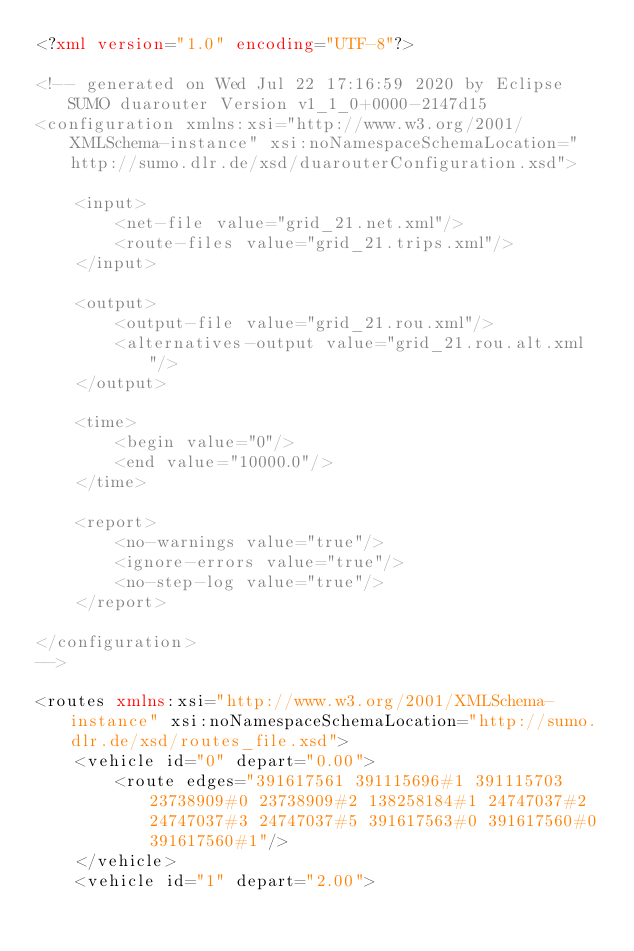<code> <loc_0><loc_0><loc_500><loc_500><_XML_><?xml version="1.0" encoding="UTF-8"?>

<!-- generated on Wed Jul 22 17:16:59 2020 by Eclipse SUMO duarouter Version v1_1_0+0000-2147d15
<configuration xmlns:xsi="http://www.w3.org/2001/XMLSchema-instance" xsi:noNamespaceSchemaLocation="http://sumo.dlr.de/xsd/duarouterConfiguration.xsd">

    <input>
        <net-file value="grid_21.net.xml"/>
        <route-files value="grid_21.trips.xml"/>
    </input>

    <output>
        <output-file value="grid_21.rou.xml"/>
        <alternatives-output value="grid_21.rou.alt.xml"/>
    </output>

    <time>
        <begin value="0"/>
        <end value="10000.0"/>
    </time>

    <report>
        <no-warnings value="true"/>
        <ignore-errors value="true"/>
        <no-step-log value="true"/>
    </report>

</configuration>
-->

<routes xmlns:xsi="http://www.w3.org/2001/XMLSchema-instance" xsi:noNamespaceSchemaLocation="http://sumo.dlr.de/xsd/routes_file.xsd">
    <vehicle id="0" depart="0.00">
        <route edges="391617561 391115696#1 391115703 23738909#0 23738909#2 138258184#1 24747037#2 24747037#3 24747037#5 391617563#0 391617560#0 391617560#1"/>
    </vehicle>
    <vehicle id="1" depart="2.00"></code> 